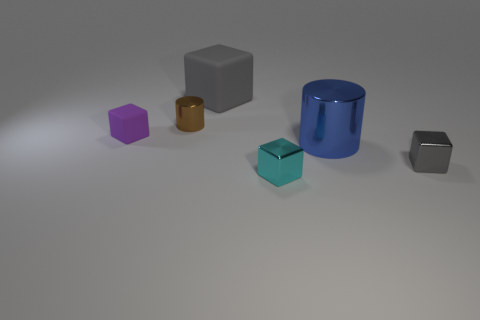Do the blue thing and the brown object have the same shape? No, they do not have the same shape. The blue object is a cylinder, characterized by its circular base and curved surface, whereas the brown object is a cube, identifiable by its six square faces and sharp edges. 